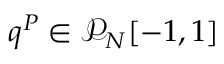<formula> <loc_0><loc_0><loc_500><loc_500>q ^ { P } \in \mathcal { P } _ { N } [ - 1 , 1 ]</formula> 